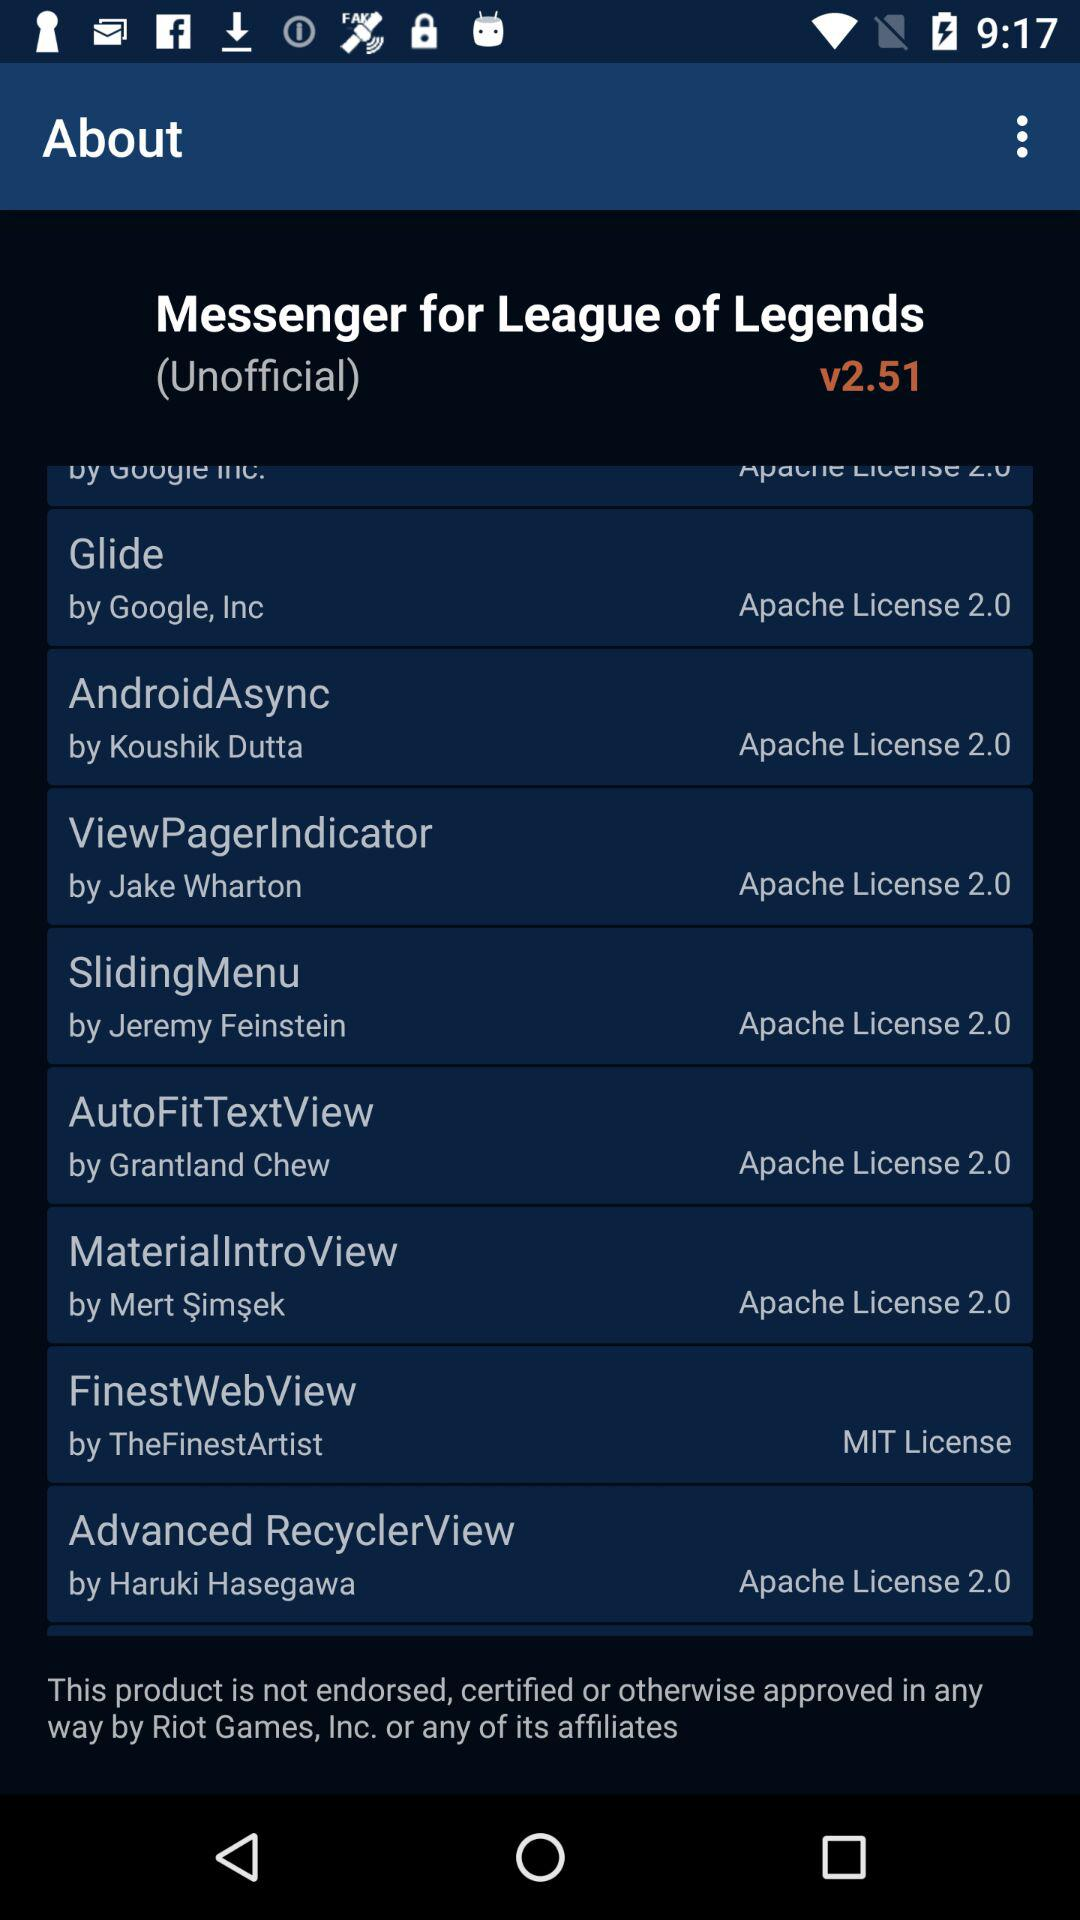What is the app name? The app name is "Messenger for League of Legends". 